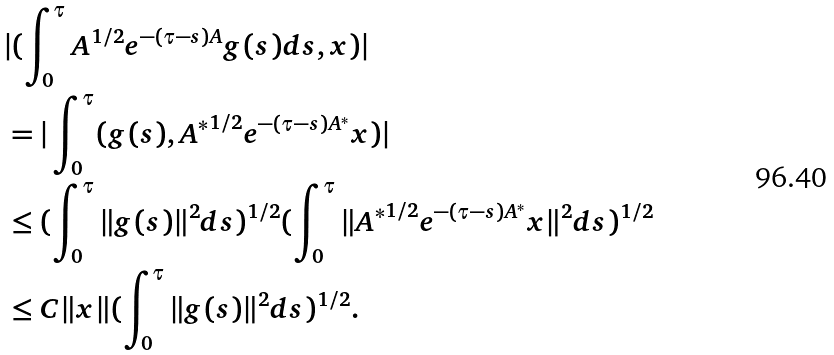<formula> <loc_0><loc_0><loc_500><loc_500>& | ( \int _ { 0 } ^ { \tau } A ^ { 1 / 2 } e ^ { - ( \tau - s ) A } g ( s ) d s , x ) | \\ & = | \int _ { 0 } ^ { \tau } ( g ( s ) , { A ^ { * } } ^ { 1 / 2 } e ^ { - ( \tau - s ) A ^ { * } } x ) | \\ & \leq ( \int _ { 0 } ^ { \tau } \| g ( s ) \| ^ { 2 } d s ) ^ { 1 / 2 } ( \int _ { 0 } ^ { \tau } \| { A ^ { * } } ^ { 1 / 2 } e ^ { - ( \tau - s ) A ^ { * } } x \| ^ { 2 } d s ) ^ { 1 / 2 } \\ & \leq C \| x \| ( \int _ { 0 } ^ { \tau } \| g ( s ) \| ^ { 2 } d s ) ^ { 1 / 2 } .</formula> 